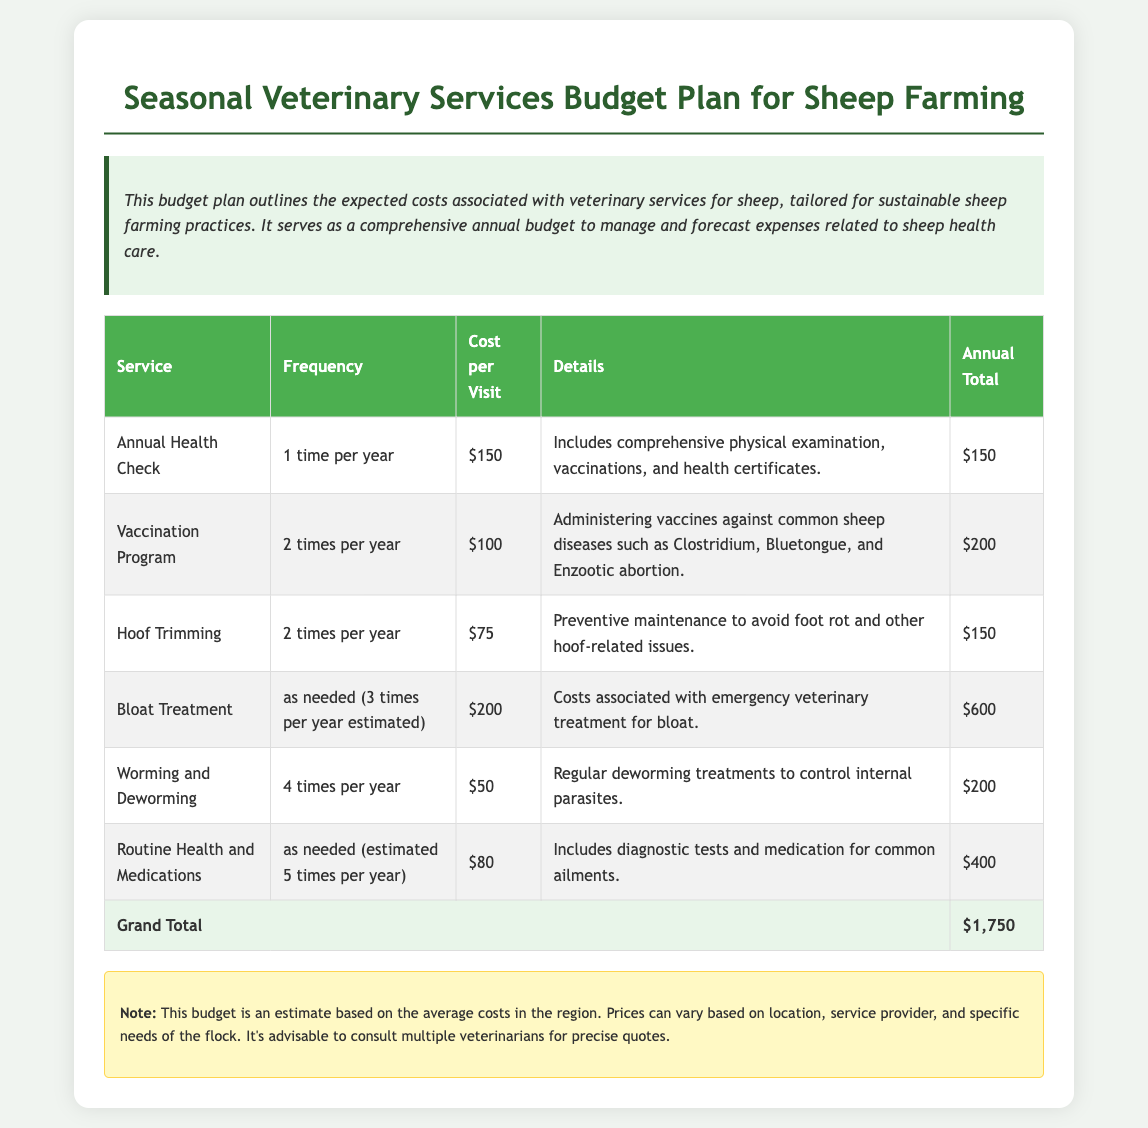What is the annual total for the vaccination program? The annual total for the vaccination program is calculated by multiplying the cost per visit, $100, by its frequency, 2 times per year, which gives a total of $200.
Answer: $200 How many times per year is hoof trimming scheduled? The document states that hoof trimming is scheduled for 2 times per year.
Answer: 2 times per year What is the cost per visit for bloat treatment? The cost per visit for bloat treatment is listed as $200 in the document.
Answer: $200 What are the estimated total annual costs for all veterinary services combined? The grand total for all veterinary services, as indicated at the bottom of the table, is $1,750.
Answer: $1,750 Which service requires the most frequent visits? The service that requires the most frequent visits is worming and deworming, which is scheduled 4 times per year.
Answer: 4 times per year What is included in the annual health check? The annual health check includes a comprehensive physical examination, vaccinations, and health certificates.
Answer: Comprehensive physical examination, vaccinations, and health certificates What is the total cost for routine health and medications? The total cost for routine health and medications is calculated by estimating it at 5 times per year at $80 each, resulting in $400.
Answer: $400 How many estimated emergency visits for bloat are included? The document estimates 3 emergency visits for bloat treatment per year.
Answer: 3 times per year What type of budget is this document outlining? This document outlines a budget for seasonal veterinary services for sheep farming.
Answer: Seasonal veterinary services budget 